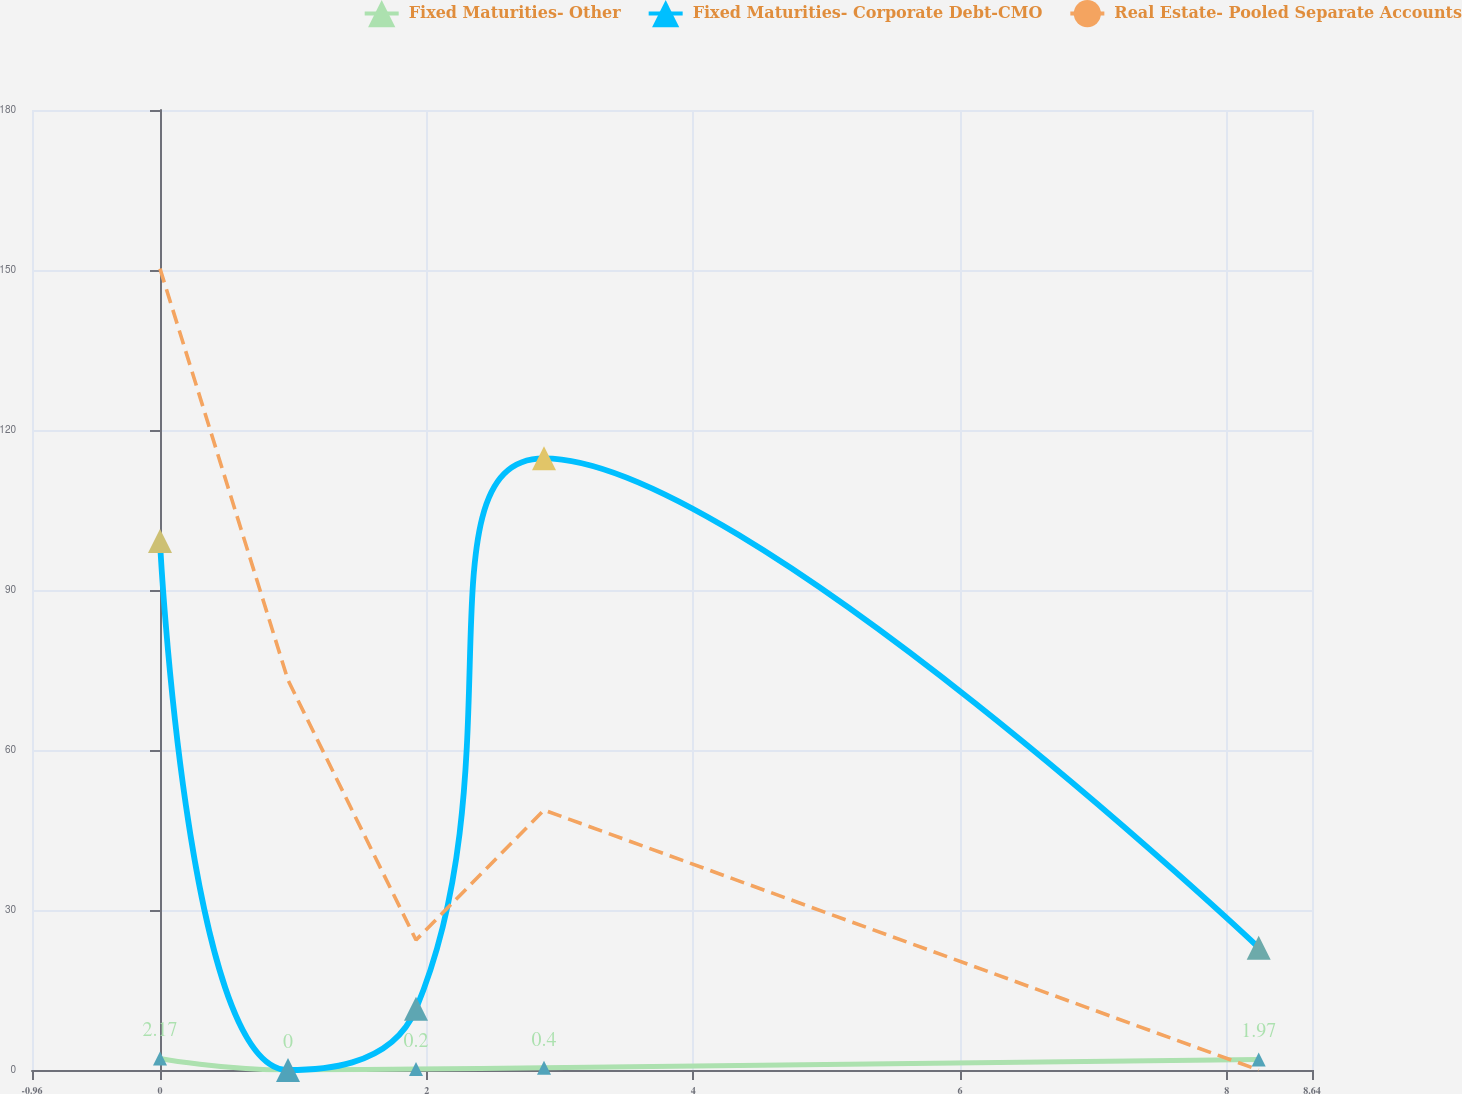<chart> <loc_0><loc_0><loc_500><loc_500><line_chart><ecel><fcel>Fixed Maturities- Other<fcel>Fixed Maturities- Corporate Debt-CMO<fcel>Real Estate- Pooled Separate Accounts<nl><fcel>0<fcel>2.17<fcel>99.18<fcel>150.26<nl><fcel>0.96<fcel>0<fcel>0<fcel>73.11<nl><fcel>1.92<fcel>0.2<fcel>11.47<fcel>24.37<nl><fcel>2.88<fcel>0.4<fcel>114.68<fcel>48.74<nl><fcel>8.24<fcel>1.97<fcel>22.94<fcel>0<nl><fcel>9.6<fcel>0.6<fcel>34.41<fcel>243.71<nl></chart> 